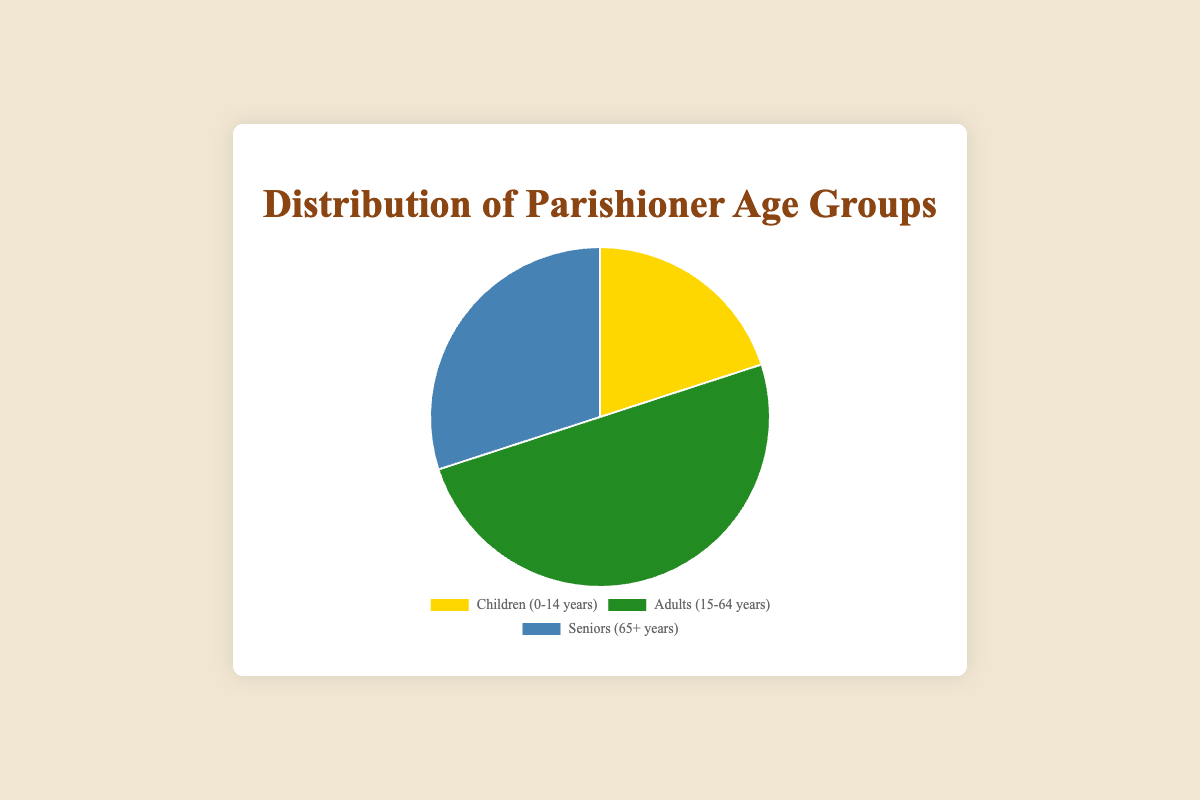What is the percentage of parishioners who are children? According to the pie chart, the percentage of parishioners in the "Children (0-14 years)" age group is explicitly shown as 20%.
Answer: 20% Which age group has the highest percentage of parishioners? By examining the pie chart, we can see that the "Adults (15-64 years)" age group has the highest percentage at 50%.
Answer: Adults (15-64 years) What is the difference in percentage between the adults and the seniors groups? According to the pie chart, the percentage of adults is 50%, and the percentage of seniors is 30%. The difference is 50% - 30% = 20%.
Answer: 20% Which age group represents the smallest percentage of parishioners? The pie chart shows that the "Children (0-14 years)" age group has the smallest percentage, which is 20%.
Answer: Children (0-14 years) If you combine the percentages of children and seniors, what percentage of the parishioners do they represent? From the pie chart, children represent 20%, and seniors represent 30%. Combining these percentages, 20% + 30% = 50%.
Answer: 50% How much greater is the percentage of adults compared to children? According to the pie chart, the percentage of adults is 50%, and the percentage of children is 20%. The difference is 50% - 20% = 30%.
Answer: 30% What is the average percentage of parishioners across the three age groups? The percentages of the age groups are 20%, 50%, and 30%. The average is calculated as (20% + 50% + 30%) / 3 = 33.33%.
Answer: 33.33% Of the visual elements in the pie chart, which color represents the seniors age group? By examining the colors in the pie chart, it is clear that the segment representing "Seniors (65+ years)" is in blue.
Answer: Blue 